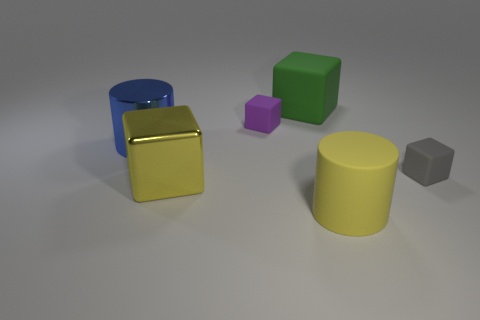What number of purple objects have the same shape as the large green rubber object?
Your response must be concise. 1. Do the tiny rubber thing left of the big green block and the large blue thing have the same shape?
Your answer should be very brief. No. There is a cube that is the same size as the gray matte thing; what is it made of?
Make the answer very short. Rubber. Are there an equal number of matte cubes that are to the right of the tiny purple block and tiny objects that are right of the small gray rubber object?
Give a very brief answer. No. There is a large matte object that is behind the big cylinder in front of the small gray cube; how many big yellow metallic objects are right of it?
Your response must be concise. 0. Does the big shiny cube have the same color as the large cube behind the big yellow block?
Provide a short and direct response. No. What is the size of the yellow block that is made of the same material as the big blue cylinder?
Your answer should be very brief. Large. Are there more large blocks behind the big green thing than big yellow cylinders?
Ensure brevity in your answer.  No. There is a tiny object that is right of the small object that is left of the big block that is behind the big blue thing; what is its material?
Offer a terse response. Rubber. Do the purple object and the tiny object in front of the big metallic cylinder have the same material?
Provide a succinct answer. Yes. 